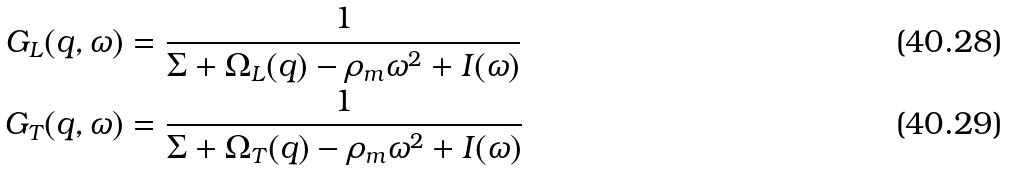Convert formula to latex. <formula><loc_0><loc_0><loc_500><loc_500>G _ { L } ( q , \omega ) & = \frac { 1 } { \Sigma + \Omega _ { L } ( q ) - \rho _ { m } \omega ^ { 2 } + I ( \omega ) } \\ G _ { T } ( q , \omega ) & = \frac { 1 } { \Sigma + \Omega _ { T } ( q ) - \rho _ { m } \omega ^ { 2 } + I ( \omega ) }</formula> 